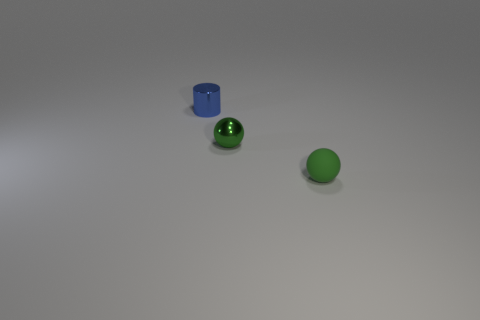Do the green rubber sphere and the cylinder have the same size?
Provide a short and direct response. Yes. How many rubber objects are either tiny green things or small purple things?
Offer a very short reply. 1. There is a green thing that is the same size as the green rubber sphere; what material is it?
Ensure brevity in your answer.  Metal. How many other things are there of the same material as the small blue cylinder?
Make the answer very short. 1. Is the number of green rubber objects that are behind the tiny blue metal thing less than the number of large purple metal things?
Give a very brief answer. No. Is the blue object the same shape as the rubber object?
Your response must be concise. No. How big is the object on the left side of the tiny green object that is to the left of the ball in front of the small green shiny object?
Your answer should be very brief. Small. What is the material of the other small green object that is the same shape as the matte object?
Give a very brief answer. Metal. There is a thing that is right of the small green object that is to the left of the small green rubber sphere; how big is it?
Your answer should be very brief. Small. What color is the tiny shiny sphere?
Provide a short and direct response. Green. 